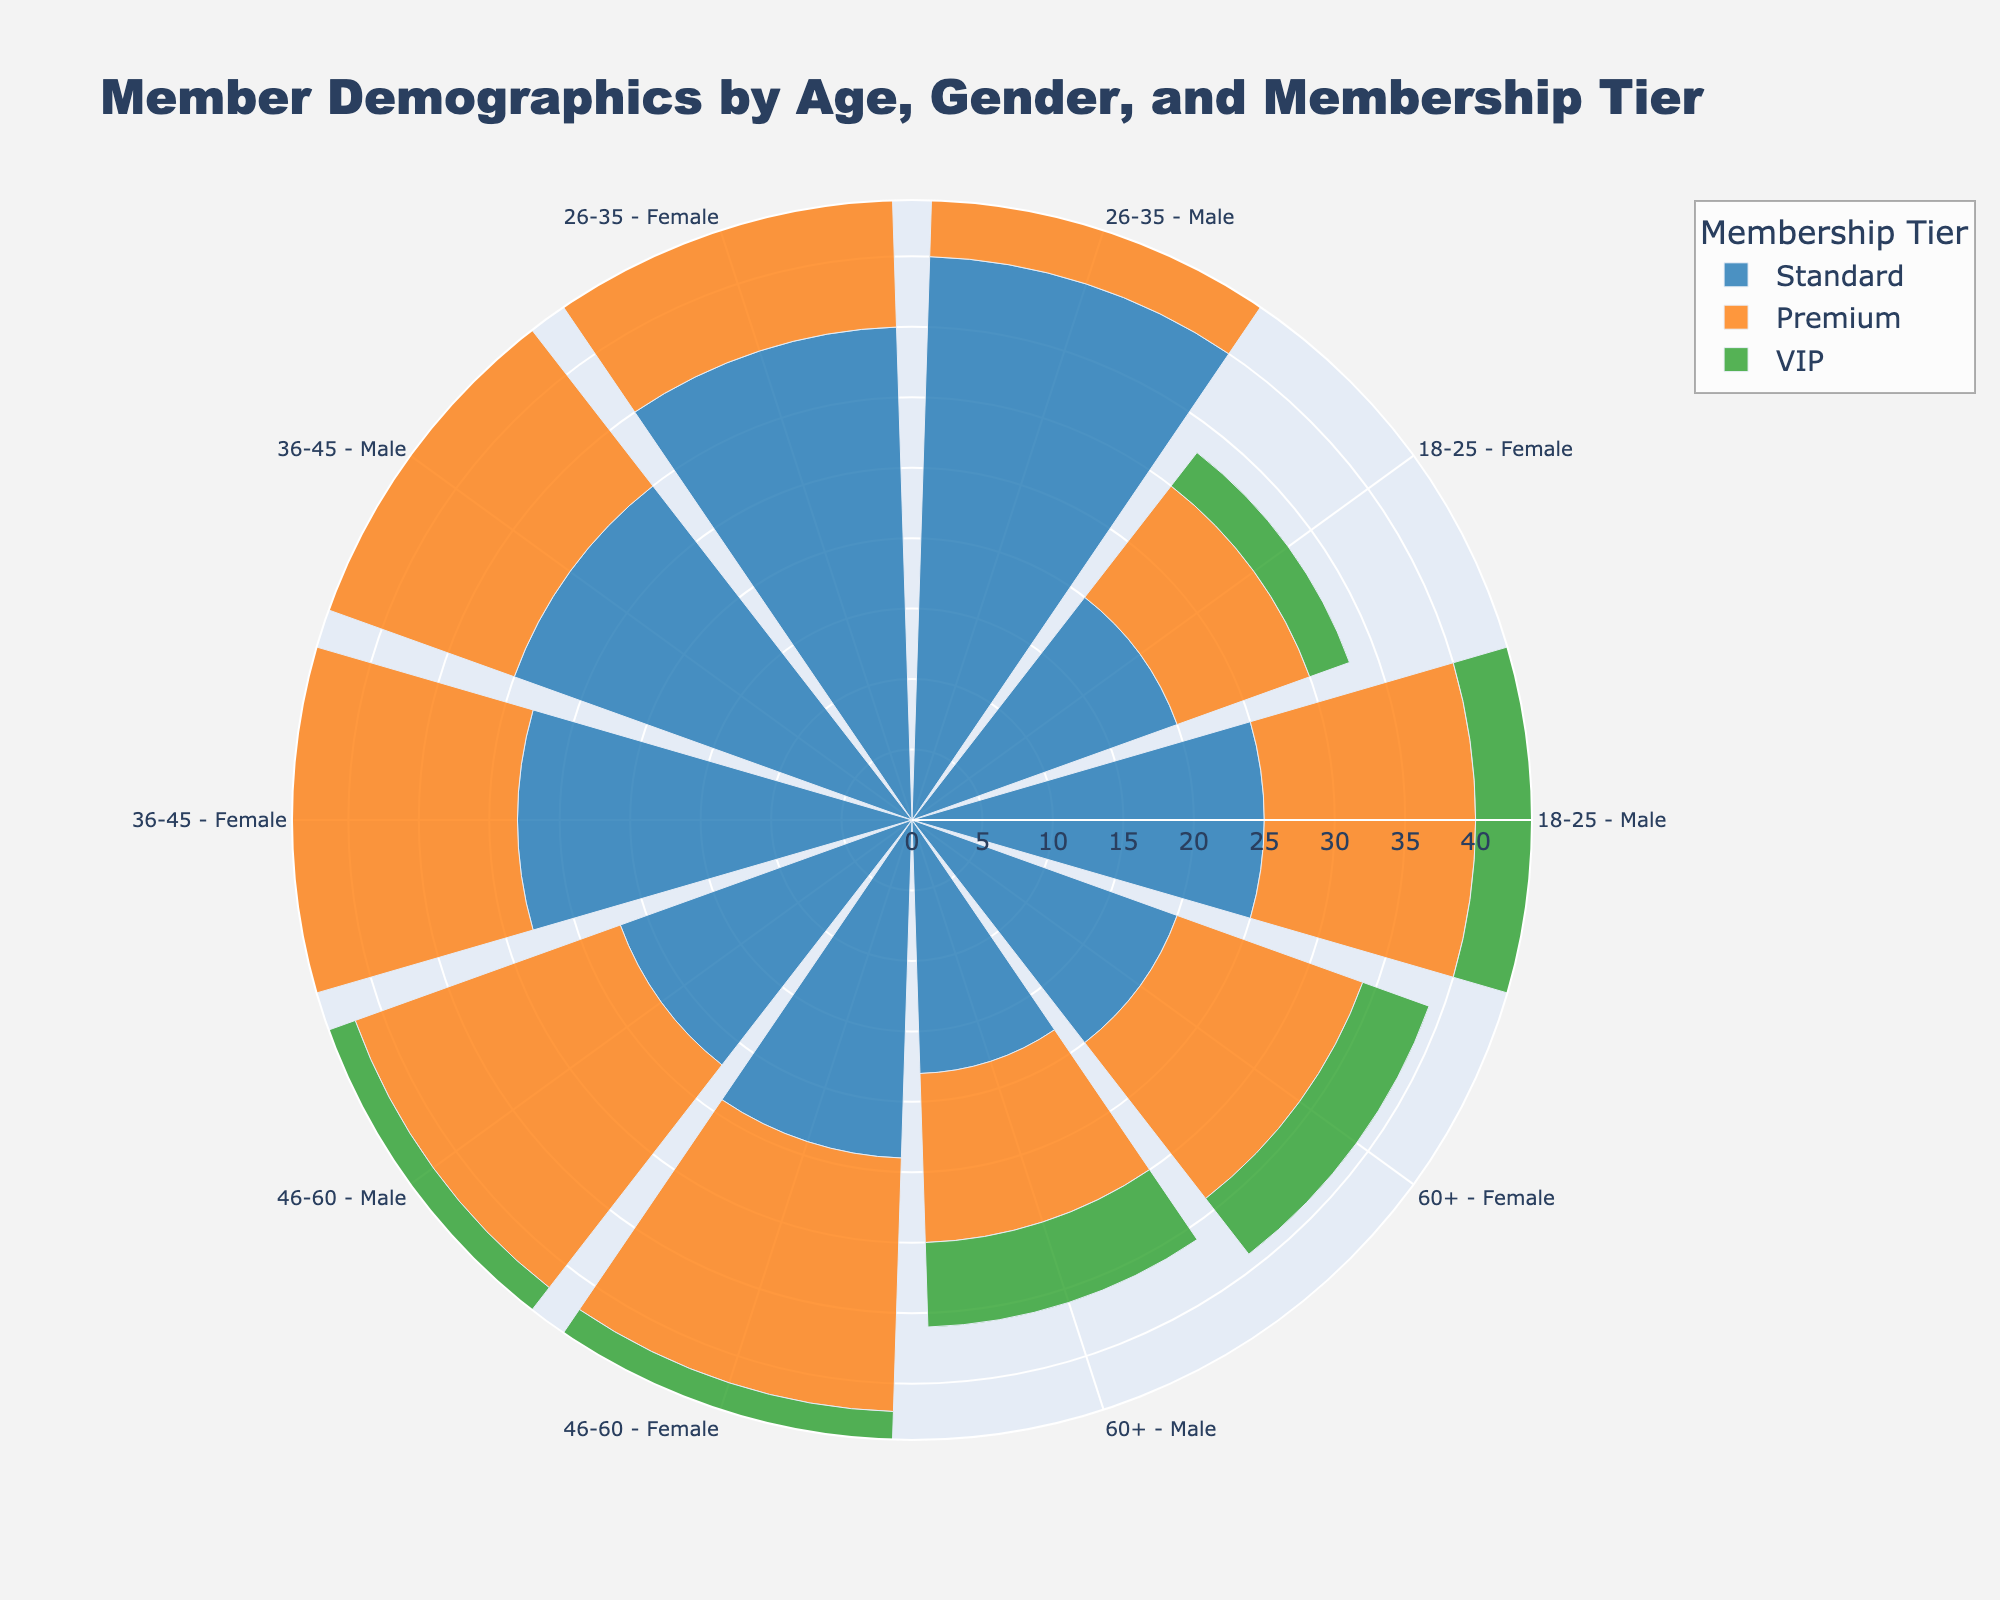What's the title of the figure? The title is usually displayed at the top of the figure. In this case, it's indicated by the "title" attribute in the layout section of the code provided. The actual title text is given directly in that attribute.
Answer: Member Demographics by Age, Gender, and Membership Tier How many age groups are there? Age groups are distinguished by the 'Age Group' attribute in the data provided. Listing the unique values from that column gives us the answer. There are five such unique groups (18-25, 26-35, 36-45, 46-60, and 60+).
Answer: 5 Which membership tier has the highest total count? To determine this, sum the counts for each membership tier (Standard, Premium, VIP) across all age and gender combinations. Standard (262), Premium (190), VIP (84). The highest total is for Standard.
Answer: Standard What is the total count for female members in the 26-35 age group? To find this, sum the counts for female members in the 26-35 age group across all membership tiers. That would be the sum of 35 (Standard), 22 (Premium), and 8 (VIP). The total is 65.
Answer: 65 What's the difference in count between male and female VIP members in the 60+ age group? Subtract the count of female VIP members (5) from the count of male VIP members (6) in the 60+ age group. The difference is 1.
Answer: 1 Which gender and membership tier have the lowest member count in the 18-25 age group? Compare the counts of all gender and membership tier combinations within the 18-25 age group. The lowest is Female VIP with a count of 3.
Answer: Female VIP What is the average count of male members in the Premium tier across all age groups? Sum the counts of male members in the Premium tier (15, 25, 28, 20, 12) and divide by the number of age groups (5). The sum is 100, so the average is 100/5 = 20.
Answer: 20 In which age group is the count of female Standard members higher than that of male Standard members? Compare the counts of male and female Standard members within each age group. The 46-60 age group shows 22 male Standard members and 24 female Standard members, where the female count is higher.
Answer: 46-60 What is the proportion of VIP members among the total members? Sum the counts for all membership tiers: Standard (262), Premium (190), and VIP (84). The total member count is 536. The proportion of VIP members is 84/536. This simplifies to approximately 0.1567.
Answer: ~0.1567 Among Standard members, in which gender and age group combination is the count closest to the average count for Standard members? Calculate the average count for Standard members (262 / 10 = 26.2). Compare this with the counts of each gender and age group combination within the Standard tier. The combination closest to this average is Female 46-60 with a count of 24.
Answer: Female 46-60 